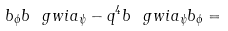<formula> <loc_0><loc_0><loc_500><loc_500>b _ { \phi } b \ g w i a _ { \psi } - q ^ { 4 } b \ g w i a _ { \psi } b _ { \phi } =</formula> 